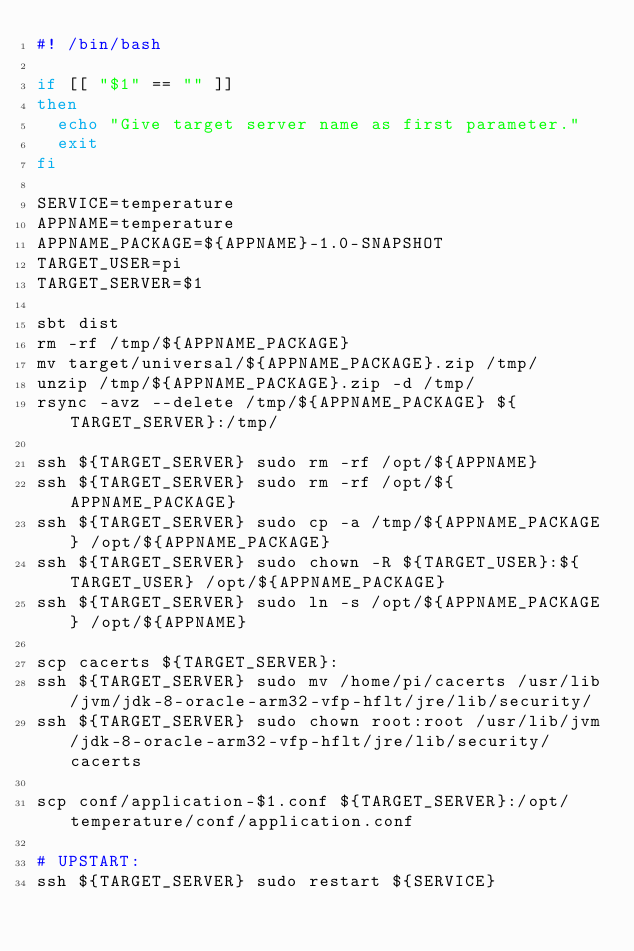Convert code to text. <code><loc_0><loc_0><loc_500><loc_500><_Bash_>#! /bin/bash

if [[ "$1" == "" ]]
then
	echo "Give target server name as first parameter."
	exit
fi

SERVICE=temperature
APPNAME=temperature
APPNAME_PACKAGE=${APPNAME}-1.0-SNAPSHOT
TARGET_USER=pi
TARGET_SERVER=$1

sbt dist
rm -rf /tmp/${APPNAME_PACKAGE}
mv target/universal/${APPNAME_PACKAGE}.zip /tmp/
unzip /tmp/${APPNAME_PACKAGE}.zip -d /tmp/
rsync -avz --delete /tmp/${APPNAME_PACKAGE} ${TARGET_SERVER}:/tmp/

ssh ${TARGET_SERVER} sudo rm -rf /opt/${APPNAME}
ssh ${TARGET_SERVER} sudo rm -rf /opt/${APPNAME_PACKAGE}
ssh ${TARGET_SERVER} sudo cp -a /tmp/${APPNAME_PACKAGE} /opt/${APPNAME_PACKAGE}
ssh ${TARGET_SERVER} sudo chown -R ${TARGET_USER}:${TARGET_USER} /opt/${APPNAME_PACKAGE}
ssh ${TARGET_SERVER} sudo ln -s /opt/${APPNAME_PACKAGE} /opt/${APPNAME}

scp cacerts ${TARGET_SERVER}:
ssh ${TARGET_SERVER} sudo mv /home/pi/cacerts /usr/lib/jvm/jdk-8-oracle-arm32-vfp-hflt/jre/lib/security/
ssh ${TARGET_SERVER} sudo chown root:root /usr/lib/jvm/jdk-8-oracle-arm32-vfp-hflt/jre/lib/security/cacerts

scp conf/application-$1.conf ${TARGET_SERVER}:/opt/temperature/conf/application.conf

# UPSTART:
ssh ${TARGET_SERVER} sudo restart ${SERVICE}

</code> 